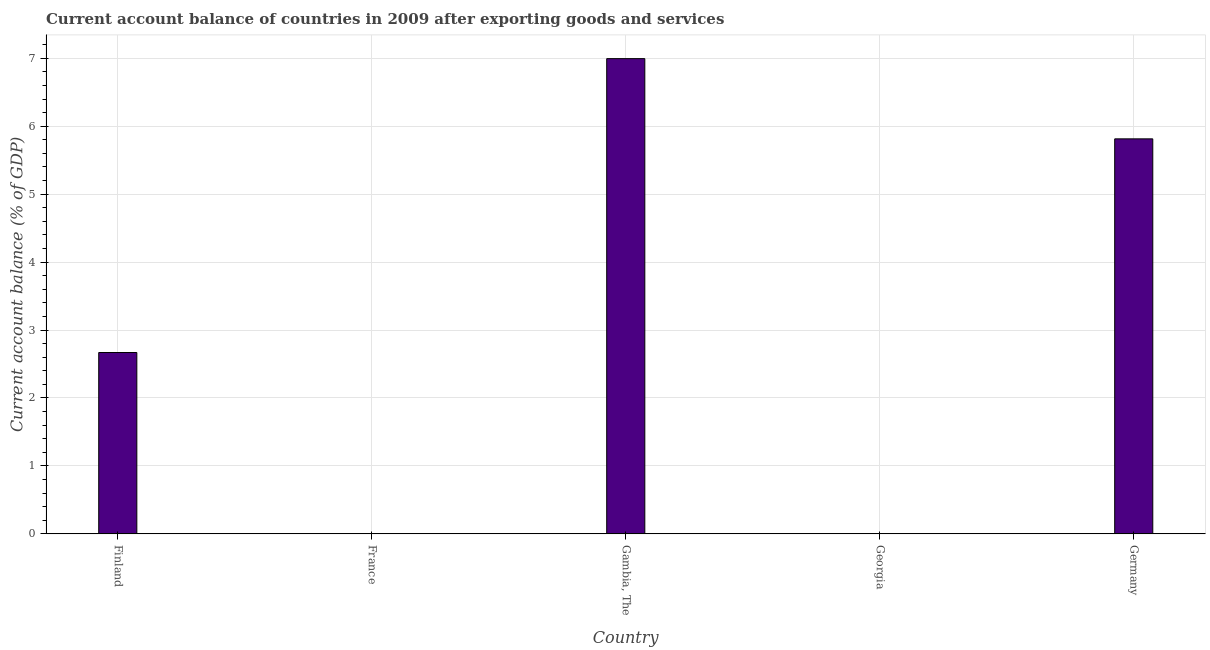Does the graph contain any zero values?
Keep it short and to the point. Yes. Does the graph contain grids?
Make the answer very short. Yes. What is the title of the graph?
Give a very brief answer. Current account balance of countries in 2009 after exporting goods and services. What is the label or title of the Y-axis?
Give a very brief answer. Current account balance (% of GDP). What is the current account balance in Germany?
Give a very brief answer. 5.81. Across all countries, what is the maximum current account balance?
Make the answer very short. 6.99. In which country was the current account balance maximum?
Give a very brief answer. Gambia, The. What is the sum of the current account balance?
Keep it short and to the point. 15.48. What is the difference between the current account balance in Gambia, The and Germany?
Offer a terse response. 1.18. What is the average current account balance per country?
Your answer should be very brief. 3.1. What is the median current account balance?
Provide a short and direct response. 2.67. What is the ratio of the current account balance in Finland to that in Gambia, The?
Your response must be concise. 0.38. Is the current account balance in Finland less than that in Germany?
Offer a terse response. Yes. Is the difference between the current account balance in Finland and Gambia, The greater than the difference between any two countries?
Your answer should be compact. No. What is the difference between the highest and the second highest current account balance?
Keep it short and to the point. 1.18. What is the difference between the highest and the lowest current account balance?
Your answer should be very brief. 6.99. In how many countries, is the current account balance greater than the average current account balance taken over all countries?
Offer a very short reply. 2. Are the values on the major ticks of Y-axis written in scientific E-notation?
Provide a succinct answer. No. What is the Current account balance (% of GDP) in Finland?
Provide a succinct answer. 2.67. What is the Current account balance (% of GDP) of France?
Give a very brief answer. 0. What is the Current account balance (% of GDP) in Gambia, The?
Your answer should be compact. 6.99. What is the Current account balance (% of GDP) in Germany?
Ensure brevity in your answer.  5.81. What is the difference between the Current account balance (% of GDP) in Finland and Gambia, The?
Make the answer very short. -4.33. What is the difference between the Current account balance (% of GDP) in Finland and Germany?
Ensure brevity in your answer.  -3.14. What is the difference between the Current account balance (% of GDP) in Gambia, The and Germany?
Your response must be concise. 1.18. What is the ratio of the Current account balance (% of GDP) in Finland to that in Gambia, The?
Ensure brevity in your answer.  0.38. What is the ratio of the Current account balance (% of GDP) in Finland to that in Germany?
Keep it short and to the point. 0.46. What is the ratio of the Current account balance (% of GDP) in Gambia, The to that in Germany?
Your answer should be very brief. 1.2. 